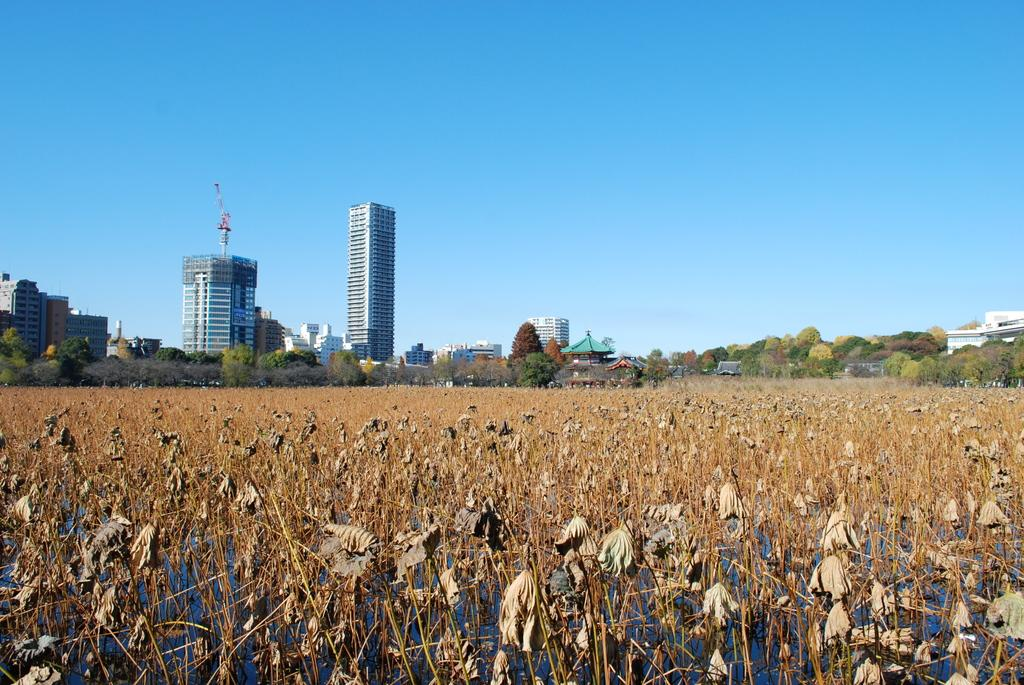What type of landscape is depicted in the image? The image appears to depict an agricultural land. What type of vegetation can be seen in the image? There are trees in the image. How many buildings can be seen in the image? There are two buildings and a small hut visible in the image. What is visible in the sky in the image? The sky is visible in the image. What structure can be seen in the image besides the buildings? There is a tower in the image. How many bikes are parked near the small hut in the image? There are no bikes visible in the image; it depicts an agricultural land with trees, buildings, and a tower. 